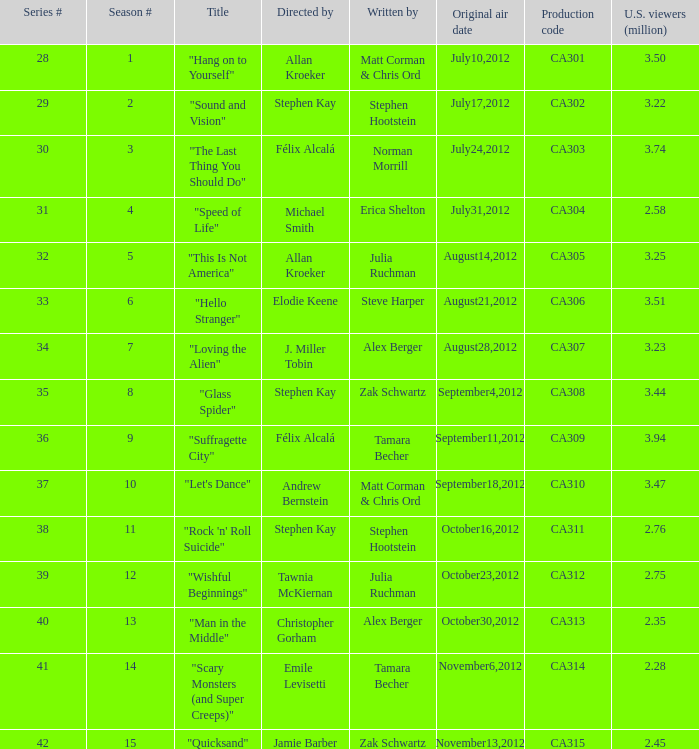What is the series episode number of the episode titled "sound and vision"? 29.0. 